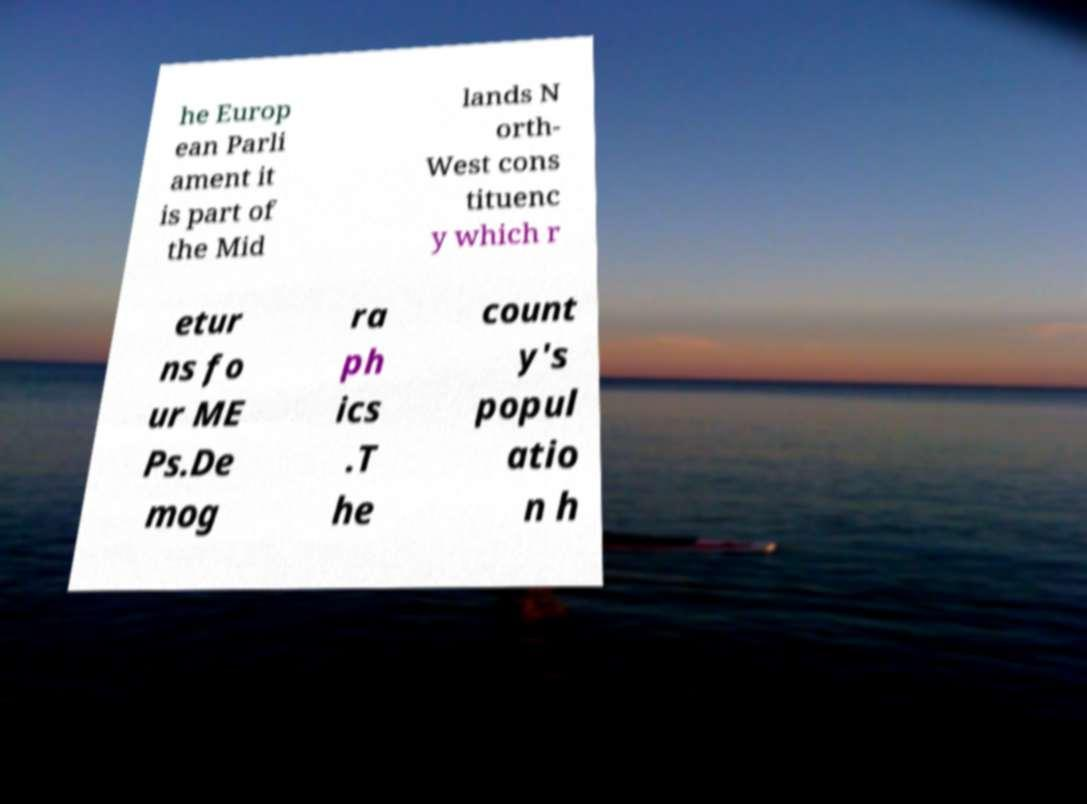What messages or text are displayed in this image? I need them in a readable, typed format. he Europ ean Parli ament it is part of the Mid lands N orth- West cons tituenc y which r etur ns fo ur ME Ps.De mog ra ph ics .T he count y's popul atio n h 